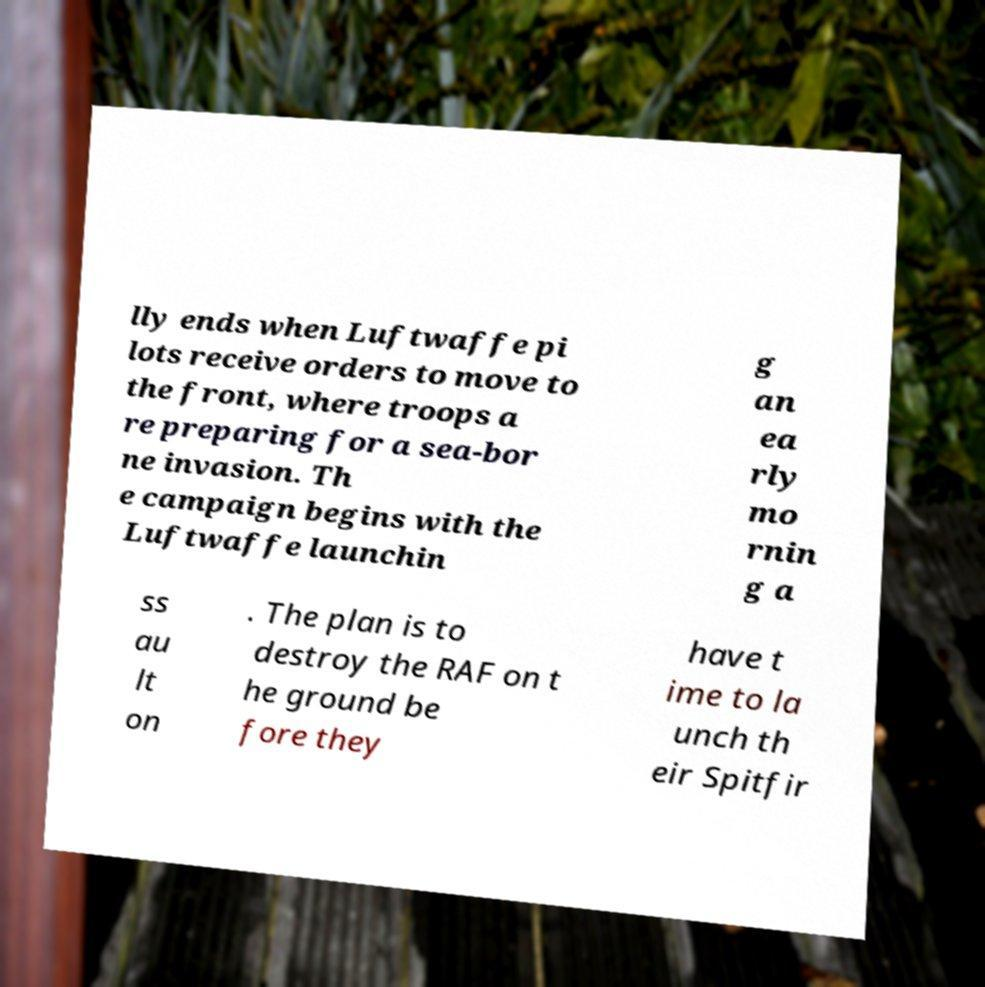Please read and relay the text visible in this image. What does it say? lly ends when Luftwaffe pi lots receive orders to move to the front, where troops a re preparing for a sea-bor ne invasion. Th e campaign begins with the Luftwaffe launchin g an ea rly mo rnin g a ss au lt on . The plan is to destroy the RAF on t he ground be fore they have t ime to la unch th eir Spitfir 